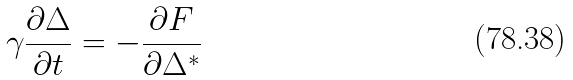<formula> <loc_0><loc_0><loc_500><loc_500>\gamma \frac { \partial \Delta } { \partial t } = - \frac { \partial F } { \partial \Delta ^ { * } }</formula> 